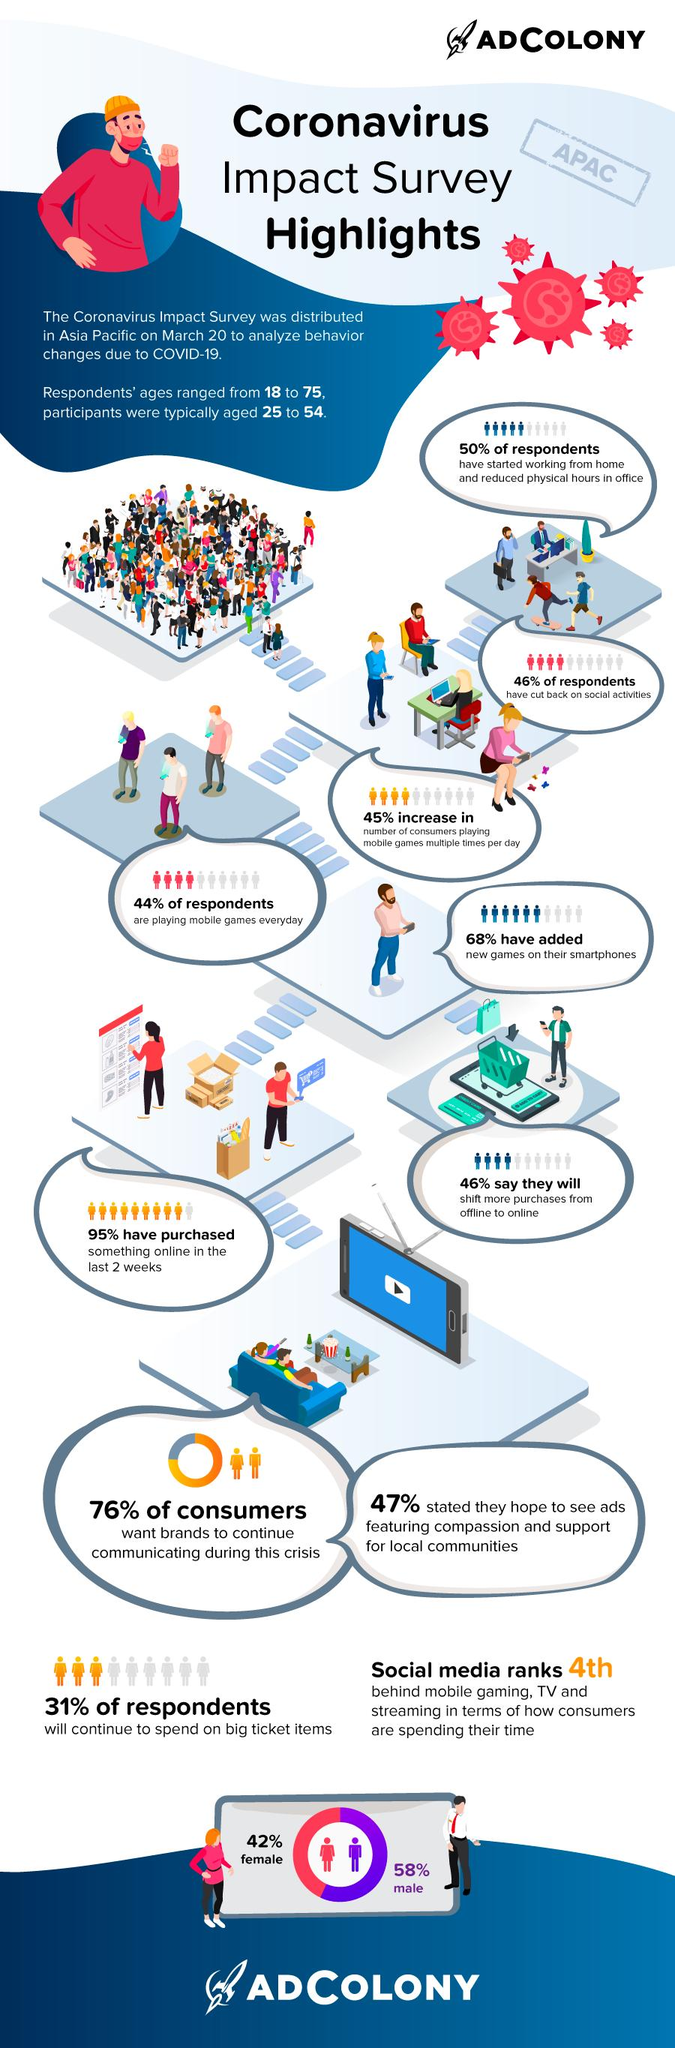Draw attention to some important aspects in this diagram. 54% of respondents do not intend to shift from offline to online mode of purchase. According to the respondents, 42% of them are females. According to the survey, an overwhelming 95% of respondents have engaged in online buying. According to the data, a significant percentage of consumers, approximately 24%, do not expect brands to continue communicating during a crisis. Sixty-eight percent of individuals have installed new games on their smartphones. 